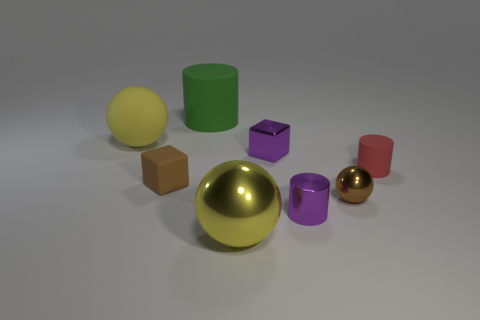Subtract all tiny cylinders. How many cylinders are left? 1 Add 1 small rubber cylinders. How many objects exist? 9 Subtract all brown cubes. How many cubes are left? 1 Subtract all cyan spheres. How many brown cubes are left? 1 Subtract all blue cubes. Subtract all cyan cylinders. How many cubes are left? 2 Subtract all tiny gray cylinders. Subtract all small brown matte blocks. How many objects are left? 7 Add 3 tiny brown metallic objects. How many tiny brown metallic objects are left? 4 Add 6 rubber spheres. How many rubber spheres exist? 7 Subtract 1 purple cylinders. How many objects are left? 7 Subtract all spheres. How many objects are left? 5 